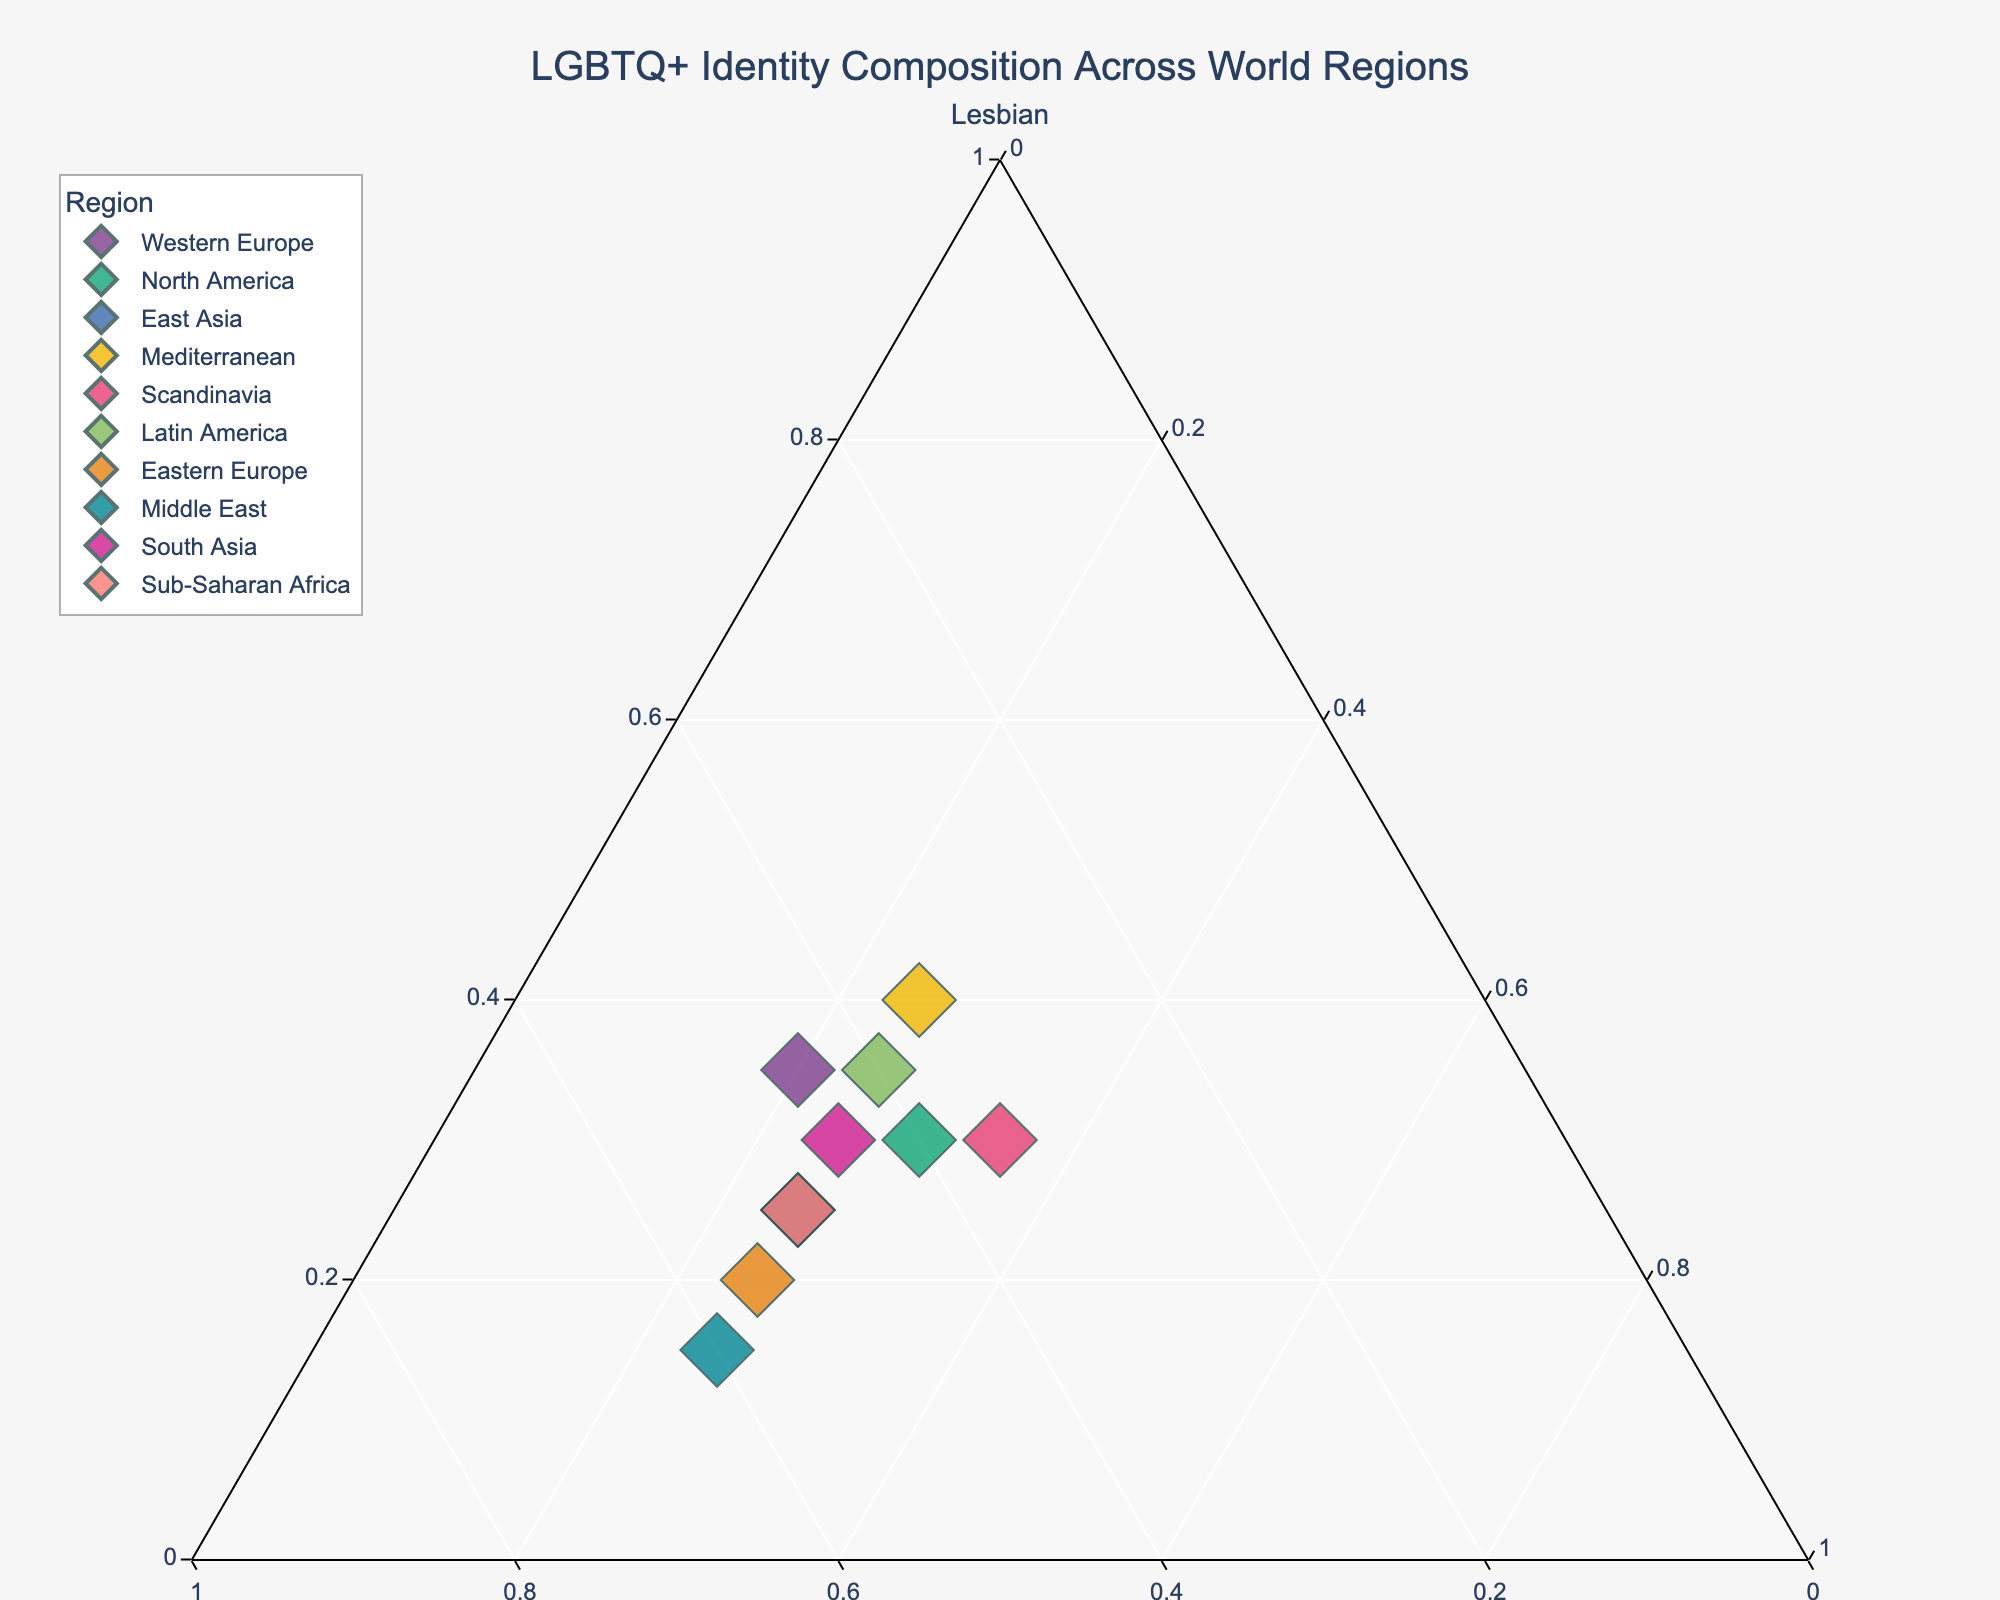what's the title of the figure? The title is usually at the top of the figure in larger and bold text, which helps to identify what the figure is about quickly. The title of this plot is "LGBTQ+ Identity Composition Across World Regions" as described.
Answer: LGBTQ+ Identity Composition Across World Regions how many regions are plotted? There is a legend that lists all the regions, and you can count the number of unique items listed. By counting each, there are 10 regions plotted in the figure.
Answer: 10 which region shows the highest proportion of Gay identities? To find this, you need to look at the axis related to 'Gay' and see which data point is closest to that axis's vertex. According to the data provided, the Middle East shows the highest proportion with 60%.
Answer: Middle East what is the sum of proportions for Gay identities in Western Europe and North America? First, note the proportions of Gay identities in Western Europe (0.45) and North America (0.40). Then, add these two values together: 0.45 + 0.40 = 0.85
Answer: 0.85 how does the Lesbian proportion in Scandinavia compare to that in Eastern Europe? Examine the proportion of 'Lesbian' in both regions. Scandinavia has 0.30, while Eastern Europe has 0.20. Since 0.30 is greater than 0.20, Scandinavia has a higher proportion of Lesbian identities.
Answer: Scandinavia has a higher proportion which region has an equal proportion of Bisexual and Gay identities? Look at the points on the plot and see which of them lie equidistantly from the 'Gay' and 'Bisexual' axis vertices. Scandinavia has both Bisexual and Gay proportions of 0.35 each.
Answer: Scandinavia is there any region where the proportion of Lesbian identities is higher than both Gay and Bisexual identities? Check each data point to see if the 'Lesbian' value is the highest among the three for any region. Mediterranean has Lesbian (0.40) value greater than Gay (0.35) and Bisexual (0.25).
Answer: Mediterranean in which region, the Bisexual proportion leads over the Lesbian but lags behind the Gay? You need to compare each region's Bisexual, Lesbian, and Gay proportions. North America fits this as Bisexual (0.30) is greater than Lesbian (0.30) and less than Gay (0.40).
Answer: North America what is the average proportion of Lesbian identities across all regions? Add up the proportions of Lesbian identities from each region and divide by the number of regions: (0.35 + 0.30 + 0.25 + 0.40 + 0.30 + 0.35 + 0.20 + 0.15 + 0.30 + 0.25)/10 = 0.28
Answer: 0.28 